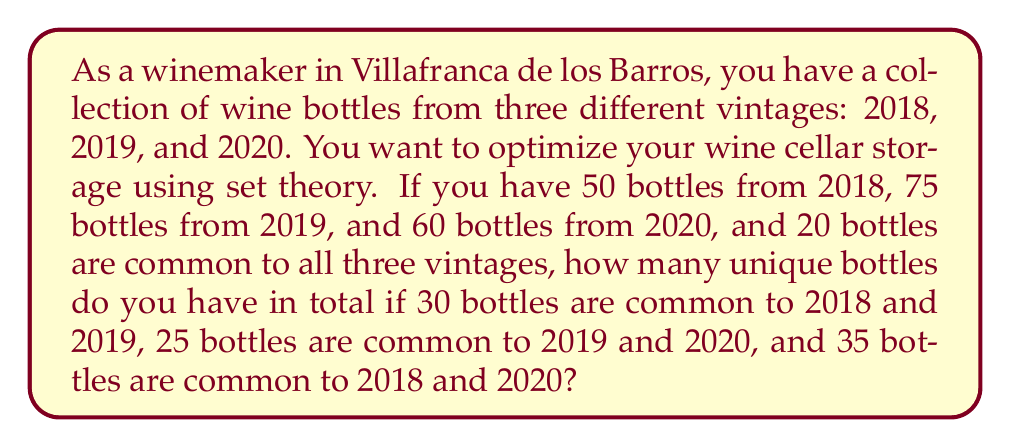Give your solution to this math problem. Let's approach this problem using set theory:

1. Define the sets:
   $A$ = bottles from 2018
   $B$ = bottles from 2019
   $C$ = bottles from 2020

2. Given information:
   $|A| = 50$, $|B| = 75$, $|C| = 60$
   $|A \cap B \cap C| = 20$
   $|A \cap B| = 30$
   $|B \cap C| = 25$
   $|A \cap C| = 35$

3. We need to find $|A \cup B \cup C|$. We can use the Inclusion-Exclusion Principle:

   $|A \cup B \cup C| = |A| + |B| + |C| - |A \cap B| - |B \cap C| - |A \cap C| + |A \cap B \cap C|$

4. Substitute the known values:

   $|A \cup B \cup C| = 50 + 75 + 60 - 30 - 25 - 35 + 20$

5. Calculate:

   $|A \cup B \cup C| = 185 - 90 + 20 = 115$

Therefore, the total number of unique bottles in your collection is 115.
Answer: 115 unique bottles 